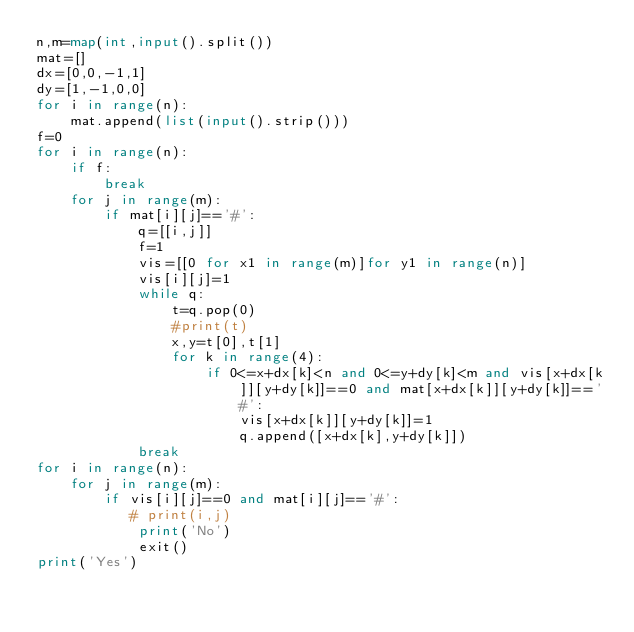<code> <loc_0><loc_0><loc_500><loc_500><_Python_>n,m=map(int,input().split())
mat=[]
dx=[0,0,-1,1]
dy=[1,-1,0,0]
for i in range(n):
    mat.append(list(input().strip()))
f=0 
for i in range(n):
    if f:
        break 
    for j in range(m):
        if mat[i][j]=='#':
            q=[[i,j]]
            f=1 
            vis=[[0 for x1 in range(m)]for y1 in range(n)]
            vis[i][j]=1 
            while q:
                t=q.pop(0)
                #print(t)
                x,y=t[0],t[1] 
                for k in range(4): 
                    if 0<=x+dx[k]<n and 0<=y+dy[k]<m and vis[x+dx[k]][y+dy[k]]==0 and mat[x+dx[k]][y+dy[k]]=='#': 
                        vis[x+dx[k]][y+dy[k]]=1 
                        q.append([x+dx[k],y+dy[k]])
            break 
for i in range(n):
    for j in range(m): 
        if vis[i][j]==0 and mat[i][j]=='#':
           # print(i,j)
            print('No')
            exit()
print('Yes')</code> 